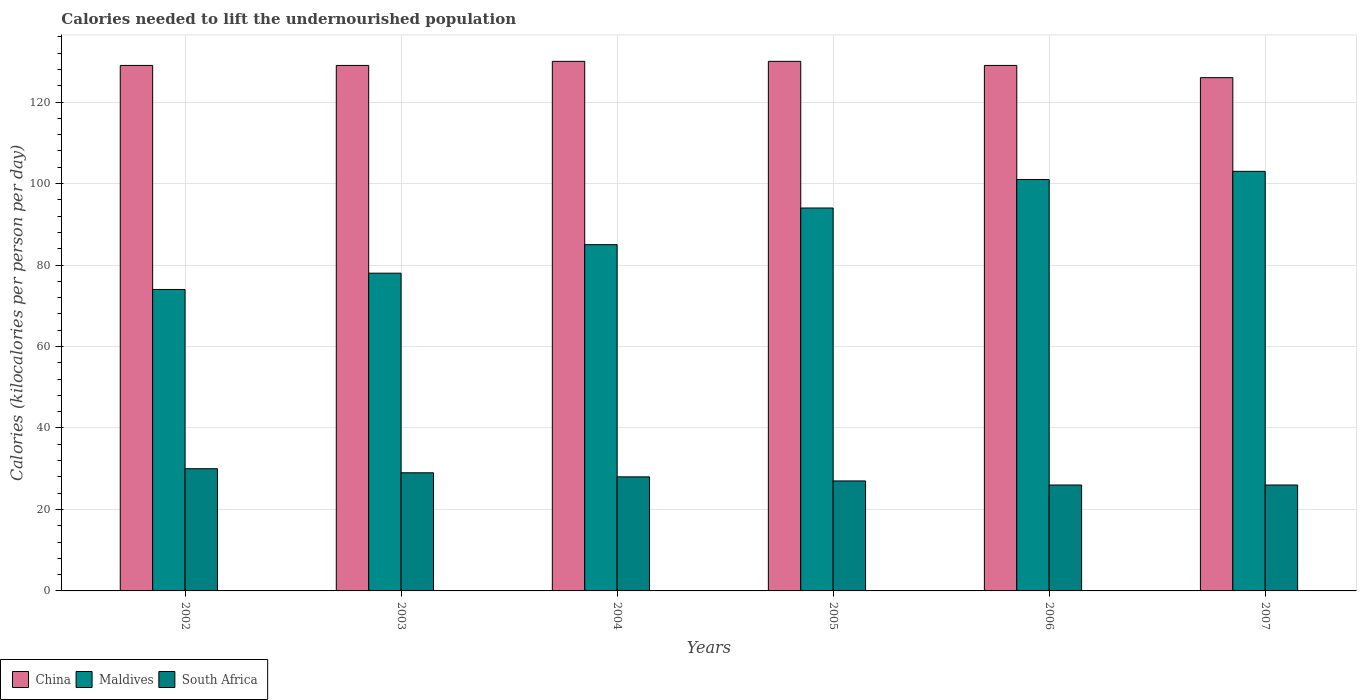How many different coloured bars are there?
Your response must be concise. 3. Are the number of bars per tick equal to the number of legend labels?
Keep it short and to the point. Yes. How many bars are there on the 3rd tick from the left?
Your answer should be compact. 3. What is the total calories needed to lift the undernourished population in China in 2003?
Ensure brevity in your answer.  129. Across all years, what is the maximum total calories needed to lift the undernourished population in South Africa?
Make the answer very short. 30. Across all years, what is the minimum total calories needed to lift the undernourished population in Maldives?
Offer a very short reply. 74. In which year was the total calories needed to lift the undernourished population in Maldives maximum?
Your answer should be compact. 2007. In which year was the total calories needed to lift the undernourished population in South Africa minimum?
Offer a very short reply. 2006. What is the total total calories needed to lift the undernourished population in Maldives in the graph?
Ensure brevity in your answer.  535. What is the difference between the total calories needed to lift the undernourished population in China in 2002 and that in 2005?
Provide a succinct answer. -1. What is the difference between the total calories needed to lift the undernourished population in South Africa in 2003 and the total calories needed to lift the undernourished population in Maldives in 2006?
Your response must be concise. -72. What is the average total calories needed to lift the undernourished population in Maldives per year?
Offer a very short reply. 89.17. In the year 2005, what is the difference between the total calories needed to lift the undernourished population in Maldives and total calories needed to lift the undernourished population in China?
Ensure brevity in your answer.  -36. In how many years, is the total calories needed to lift the undernourished population in South Africa greater than 96 kilocalories?
Your answer should be very brief. 0. What is the ratio of the total calories needed to lift the undernourished population in South Africa in 2005 to that in 2006?
Offer a terse response. 1.04. Is the total calories needed to lift the undernourished population in China in 2005 less than that in 2007?
Make the answer very short. No. Is the difference between the total calories needed to lift the undernourished population in Maldives in 2002 and 2007 greater than the difference between the total calories needed to lift the undernourished population in China in 2002 and 2007?
Your answer should be compact. No. What is the difference between the highest and the second highest total calories needed to lift the undernourished population in China?
Offer a terse response. 0. What is the difference between the highest and the lowest total calories needed to lift the undernourished population in Maldives?
Give a very brief answer. 29. Is the sum of the total calories needed to lift the undernourished population in China in 2002 and 2006 greater than the maximum total calories needed to lift the undernourished population in Maldives across all years?
Ensure brevity in your answer.  Yes. What does the 1st bar from the right in 2005 represents?
Your answer should be very brief. South Africa. Is it the case that in every year, the sum of the total calories needed to lift the undernourished population in Maldives and total calories needed to lift the undernourished population in China is greater than the total calories needed to lift the undernourished population in South Africa?
Make the answer very short. Yes. How many bars are there?
Keep it short and to the point. 18. Are all the bars in the graph horizontal?
Make the answer very short. No. What is the difference between two consecutive major ticks on the Y-axis?
Offer a terse response. 20. Does the graph contain grids?
Ensure brevity in your answer.  Yes. Where does the legend appear in the graph?
Keep it short and to the point. Bottom left. How many legend labels are there?
Your response must be concise. 3. How are the legend labels stacked?
Ensure brevity in your answer.  Horizontal. What is the title of the graph?
Offer a terse response. Calories needed to lift the undernourished population. Does "Uruguay" appear as one of the legend labels in the graph?
Make the answer very short. No. What is the label or title of the Y-axis?
Ensure brevity in your answer.  Calories (kilocalories per person per day). What is the Calories (kilocalories per person per day) of China in 2002?
Your answer should be very brief. 129. What is the Calories (kilocalories per person per day) of Maldives in 2002?
Make the answer very short. 74. What is the Calories (kilocalories per person per day) of China in 2003?
Your answer should be very brief. 129. What is the Calories (kilocalories per person per day) of Maldives in 2003?
Provide a short and direct response. 78. What is the Calories (kilocalories per person per day) in South Africa in 2003?
Make the answer very short. 29. What is the Calories (kilocalories per person per day) of China in 2004?
Make the answer very short. 130. What is the Calories (kilocalories per person per day) of Maldives in 2004?
Your answer should be very brief. 85. What is the Calories (kilocalories per person per day) in South Africa in 2004?
Your answer should be compact. 28. What is the Calories (kilocalories per person per day) in China in 2005?
Offer a very short reply. 130. What is the Calories (kilocalories per person per day) in Maldives in 2005?
Offer a very short reply. 94. What is the Calories (kilocalories per person per day) of South Africa in 2005?
Give a very brief answer. 27. What is the Calories (kilocalories per person per day) in China in 2006?
Ensure brevity in your answer.  129. What is the Calories (kilocalories per person per day) in Maldives in 2006?
Your answer should be compact. 101. What is the Calories (kilocalories per person per day) in South Africa in 2006?
Offer a very short reply. 26. What is the Calories (kilocalories per person per day) in China in 2007?
Your response must be concise. 126. What is the Calories (kilocalories per person per day) in Maldives in 2007?
Ensure brevity in your answer.  103. Across all years, what is the maximum Calories (kilocalories per person per day) in China?
Your answer should be very brief. 130. Across all years, what is the maximum Calories (kilocalories per person per day) in Maldives?
Offer a terse response. 103. Across all years, what is the maximum Calories (kilocalories per person per day) in South Africa?
Your answer should be very brief. 30. Across all years, what is the minimum Calories (kilocalories per person per day) in China?
Your answer should be very brief. 126. Across all years, what is the minimum Calories (kilocalories per person per day) in Maldives?
Your answer should be very brief. 74. What is the total Calories (kilocalories per person per day) of China in the graph?
Make the answer very short. 773. What is the total Calories (kilocalories per person per day) of Maldives in the graph?
Make the answer very short. 535. What is the total Calories (kilocalories per person per day) in South Africa in the graph?
Your answer should be compact. 166. What is the difference between the Calories (kilocalories per person per day) in Maldives in 2002 and that in 2003?
Your answer should be compact. -4. What is the difference between the Calories (kilocalories per person per day) of China in 2002 and that in 2004?
Your answer should be very brief. -1. What is the difference between the Calories (kilocalories per person per day) in South Africa in 2002 and that in 2004?
Your response must be concise. 2. What is the difference between the Calories (kilocalories per person per day) in Maldives in 2002 and that in 2005?
Provide a succinct answer. -20. What is the difference between the Calories (kilocalories per person per day) of South Africa in 2002 and that in 2005?
Provide a succinct answer. 3. What is the difference between the Calories (kilocalories per person per day) in Maldives in 2002 and that in 2006?
Offer a terse response. -27. What is the difference between the Calories (kilocalories per person per day) of South Africa in 2002 and that in 2006?
Your answer should be compact. 4. What is the difference between the Calories (kilocalories per person per day) of China in 2002 and that in 2007?
Ensure brevity in your answer.  3. What is the difference between the Calories (kilocalories per person per day) in South Africa in 2002 and that in 2007?
Provide a short and direct response. 4. What is the difference between the Calories (kilocalories per person per day) in China in 2003 and that in 2004?
Give a very brief answer. -1. What is the difference between the Calories (kilocalories per person per day) in Maldives in 2003 and that in 2004?
Your response must be concise. -7. What is the difference between the Calories (kilocalories per person per day) of South Africa in 2003 and that in 2004?
Provide a short and direct response. 1. What is the difference between the Calories (kilocalories per person per day) of China in 2003 and that in 2005?
Make the answer very short. -1. What is the difference between the Calories (kilocalories per person per day) in Maldives in 2003 and that in 2005?
Ensure brevity in your answer.  -16. What is the difference between the Calories (kilocalories per person per day) of South Africa in 2003 and that in 2005?
Provide a succinct answer. 2. What is the difference between the Calories (kilocalories per person per day) of China in 2003 and that in 2006?
Offer a terse response. 0. What is the difference between the Calories (kilocalories per person per day) of Maldives in 2003 and that in 2006?
Give a very brief answer. -23. What is the difference between the Calories (kilocalories per person per day) in China in 2003 and that in 2007?
Your answer should be very brief. 3. What is the difference between the Calories (kilocalories per person per day) in China in 2004 and that in 2005?
Your answer should be compact. 0. What is the difference between the Calories (kilocalories per person per day) in China in 2004 and that in 2006?
Offer a very short reply. 1. What is the difference between the Calories (kilocalories per person per day) in Maldives in 2004 and that in 2006?
Your answer should be compact. -16. What is the difference between the Calories (kilocalories per person per day) of Maldives in 2004 and that in 2007?
Your answer should be compact. -18. What is the difference between the Calories (kilocalories per person per day) in China in 2005 and that in 2006?
Your answer should be compact. 1. What is the difference between the Calories (kilocalories per person per day) in South Africa in 2005 and that in 2006?
Your answer should be very brief. 1. What is the difference between the Calories (kilocalories per person per day) of China in 2005 and that in 2007?
Offer a terse response. 4. What is the difference between the Calories (kilocalories per person per day) in Maldives in 2005 and that in 2007?
Offer a very short reply. -9. What is the difference between the Calories (kilocalories per person per day) in Maldives in 2006 and that in 2007?
Give a very brief answer. -2. What is the difference between the Calories (kilocalories per person per day) of South Africa in 2006 and that in 2007?
Offer a very short reply. 0. What is the difference between the Calories (kilocalories per person per day) of China in 2002 and the Calories (kilocalories per person per day) of Maldives in 2003?
Offer a terse response. 51. What is the difference between the Calories (kilocalories per person per day) in China in 2002 and the Calories (kilocalories per person per day) in South Africa in 2003?
Offer a terse response. 100. What is the difference between the Calories (kilocalories per person per day) of Maldives in 2002 and the Calories (kilocalories per person per day) of South Africa in 2003?
Offer a terse response. 45. What is the difference between the Calories (kilocalories per person per day) of China in 2002 and the Calories (kilocalories per person per day) of South Africa in 2004?
Your answer should be very brief. 101. What is the difference between the Calories (kilocalories per person per day) in China in 2002 and the Calories (kilocalories per person per day) in Maldives in 2005?
Ensure brevity in your answer.  35. What is the difference between the Calories (kilocalories per person per day) of China in 2002 and the Calories (kilocalories per person per day) of South Africa in 2005?
Your answer should be compact. 102. What is the difference between the Calories (kilocalories per person per day) of Maldives in 2002 and the Calories (kilocalories per person per day) of South Africa in 2005?
Ensure brevity in your answer.  47. What is the difference between the Calories (kilocalories per person per day) in China in 2002 and the Calories (kilocalories per person per day) in South Africa in 2006?
Provide a succinct answer. 103. What is the difference between the Calories (kilocalories per person per day) of Maldives in 2002 and the Calories (kilocalories per person per day) of South Africa in 2006?
Your answer should be compact. 48. What is the difference between the Calories (kilocalories per person per day) of China in 2002 and the Calories (kilocalories per person per day) of South Africa in 2007?
Make the answer very short. 103. What is the difference between the Calories (kilocalories per person per day) in China in 2003 and the Calories (kilocalories per person per day) in Maldives in 2004?
Ensure brevity in your answer.  44. What is the difference between the Calories (kilocalories per person per day) in China in 2003 and the Calories (kilocalories per person per day) in South Africa in 2004?
Your answer should be very brief. 101. What is the difference between the Calories (kilocalories per person per day) of China in 2003 and the Calories (kilocalories per person per day) of South Africa in 2005?
Make the answer very short. 102. What is the difference between the Calories (kilocalories per person per day) in Maldives in 2003 and the Calories (kilocalories per person per day) in South Africa in 2005?
Your response must be concise. 51. What is the difference between the Calories (kilocalories per person per day) of China in 2003 and the Calories (kilocalories per person per day) of South Africa in 2006?
Keep it short and to the point. 103. What is the difference between the Calories (kilocalories per person per day) of China in 2003 and the Calories (kilocalories per person per day) of South Africa in 2007?
Give a very brief answer. 103. What is the difference between the Calories (kilocalories per person per day) in Maldives in 2003 and the Calories (kilocalories per person per day) in South Africa in 2007?
Ensure brevity in your answer.  52. What is the difference between the Calories (kilocalories per person per day) of China in 2004 and the Calories (kilocalories per person per day) of South Africa in 2005?
Offer a terse response. 103. What is the difference between the Calories (kilocalories per person per day) of China in 2004 and the Calories (kilocalories per person per day) of South Africa in 2006?
Make the answer very short. 104. What is the difference between the Calories (kilocalories per person per day) in China in 2004 and the Calories (kilocalories per person per day) in Maldives in 2007?
Your response must be concise. 27. What is the difference between the Calories (kilocalories per person per day) in China in 2004 and the Calories (kilocalories per person per day) in South Africa in 2007?
Keep it short and to the point. 104. What is the difference between the Calories (kilocalories per person per day) in Maldives in 2004 and the Calories (kilocalories per person per day) in South Africa in 2007?
Give a very brief answer. 59. What is the difference between the Calories (kilocalories per person per day) of China in 2005 and the Calories (kilocalories per person per day) of Maldives in 2006?
Provide a succinct answer. 29. What is the difference between the Calories (kilocalories per person per day) of China in 2005 and the Calories (kilocalories per person per day) of South Africa in 2006?
Your answer should be very brief. 104. What is the difference between the Calories (kilocalories per person per day) in Maldives in 2005 and the Calories (kilocalories per person per day) in South Africa in 2006?
Make the answer very short. 68. What is the difference between the Calories (kilocalories per person per day) of China in 2005 and the Calories (kilocalories per person per day) of Maldives in 2007?
Your answer should be very brief. 27. What is the difference between the Calories (kilocalories per person per day) in China in 2005 and the Calories (kilocalories per person per day) in South Africa in 2007?
Offer a very short reply. 104. What is the difference between the Calories (kilocalories per person per day) in China in 2006 and the Calories (kilocalories per person per day) in South Africa in 2007?
Offer a very short reply. 103. What is the average Calories (kilocalories per person per day) in China per year?
Provide a short and direct response. 128.83. What is the average Calories (kilocalories per person per day) of Maldives per year?
Your answer should be compact. 89.17. What is the average Calories (kilocalories per person per day) of South Africa per year?
Offer a very short reply. 27.67. In the year 2003, what is the difference between the Calories (kilocalories per person per day) in China and Calories (kilocalories per person per day) in Maldives?
Provide a succinct answer. 51. In the year 2003, what is the difference between the Calories (kilocalories per person per day) of China and Calories (kilocalories per person per day) of South Africa?
Offer a very short reply. 100. In the year 2004, what is the difference between the Calories (kilocalories per person per day) in China and Calories (kilocalories per person per day) in Maldives?
Your answer should be compact. 45. In the year 2004, what is the difference between the Calories (kilocalories per person per day) of China and Calories (kilocalories per person per day) of South Africa?
Offer a terse response. 102. In the year 2004, what is the difference between the Calories (kilocalories per person per day) of Maldives and Calories (kilocalories per person per day) of South Africa?
Offer a very short reply. 57. In the year 2005, what is the difference between the Calories (kilocalories per person per day) of China and Calories (kilocalories per person per day) of South Africa?
Offer a terse response. 103. In the year 2005, what is the difference between the Calories (kilocalories per person per day) in Maldives and Calories (kilocalories per person per day) in South Africa?
Your response must be concise. 67. In the year 2006, what is the difference between the Calories (kilocalories per person per day) of China and Calories (kilocalories per person per day) of Maldives?
Make the answer very short. 28. In the year 2006, what is the difference between the Calories (kilocalories per person per day) of China and Calories (kilocalories per person per day) of South Africa?
Provide a short and direct response. 103. In the year 2007, what is the difference between the Calories (kilocalories per person per day) of Maldives and Calories (kilocalories per person per day) of South Africa?
Keep it short and to the point. 77. What is the ratio of the Calories (kilocalories per person per day) in China in 2002 to that in 2003?
Offer a very short reply. 1. What is the ratio of the Calories (kilocalories per person per day) in Maldives in 2002 to that in 2003?
Keep it short and to the point. 0.95. What is the ratio of the Calories (kilocalories per person per day) of South Africa in 2002 to that in 2003?
Keep it short and to the point. 1.03. What is the ratio of the Calories (kilocalories per person per day) in China in 2002 to that in 2004?
Give a very brief answer. 0.99. What is the ratio of the Calories (kilocalories per person per day) in Maldives in 2002 to that in 2004?
Ensure brevity in your answer.  0.87. What is the ratio of the Calories (kilocalories per person per day) of South Africa in 2002 to that in 2004?
Ensure brevity in your answer.  1.07. What is the ratio of the Calories (kilocalories per person per day) of Maldives in 2002 to that in 2005?
Provide a succinct answer. 0.79. What is the ratio of the Calories (kilocalories per person per day) in Maldives in 2002 to that in 2006?
Provide a succinct answer. 0.73. What is the ratio of the Calories (kilocalories per person per day) in South Africa in 2002 to that in 2006?
Your answer should be compact. 1.15. What is the ratio of the Calories (kilocalories per person per day) in China in 2002 to that in 2007?
Your response must be concise. 1.02. What is the ratio of the Calories (kilocalories per person per day) in Maldives in 2002 to that in 2007?
Provide a succinct answer. 0.72. What is the ratio of the Calories (kilocalories per person per day) in South Africa in 2002 to that in 2007?
Provide a succinct answer. 1.15. What is the ratio of the Calories (kilocalories per person per day) of Maldives in 2003 to that in 2004?
Ensure brevity in your answer.  0.92. What is the ratio of the Calories (kilocalories per person per day) of South Africa in 2003 to that in 2004?
Ensure brevity in your answer.  1.04. What is the ratio of the Calories (kilocalories per person per day) in Maldives in 2003 to that in 2005?
Your answer should be compact. 0.83. What is the ratio of the Calories (kilocalories per person per day) of South Africa in 2003 to that in 2005?
Make the answer very short. 1.07. What is the ratio of the Calories (kilocalories per person per day) in China in 2003 to that in 2006?
Offer a terse response. 1. What is the ratio of the Calories (kilocalories per person per day) of Maldives in 2003 to that in 2006?
Make the answer very short. 0.77. What is the ratio of the Calories (kilocalories per person per day) in South Africa in 2003 to that in 2006?
Offer a very short reply. 1.12. What is the ratio of the Calories (kilocalories per person per day) in China in 2003 to that in 2007?
Your answer should be very brief. 1.02. What is the ratio of the Calories (kilocalories per person per day) of Maldives in 2003 to that in 2007?
Your response must be concise. 0.76. What is the ratio of the Calories (kilocalories per person per day) of South Africa in 2003 to that in 2007?
Your answer should be very brief. 1.12. What is the ratio of the Calories (kilocalories per person per day) of Maldives in 2004 to that in 2005?
Keep it short and to the point. 0.9. What is the ratio of the Calories (kilocalories per person per day) in South Africa in 2004 to that in 2005?
Keep it short and to the point. 1.04. What is the ratio of the Calories (kilocalories per person per day) of China in 2004 to that in 2006?
Offer a terse response. 1.01. What is the ratio of the Calories (kilocalories per person per day) of Maldives in 2004 to that in 2006?
Offer a very short reply. 0.84. What is the ratio of the Calories (kilocalories per person per day) of South Africa in 2004 to that in 2006?
Offer a very short reply. 1.08. What is the ratio of the Calories (kilocalories per person per day) in China in 2004 to that in 2007?
Your answer should be very brief. 1.03. What is the ratio of the Calories (kilocalories per person per day) of Maldives in 2004 to that in 2007?
Ensure brevity in your answer.  0.83. What is the ratio of the Calories (kilocalories per person per day) of South Africa in 2004 to that in 2007?
Provide a succinct answer. 1.08. What is the ratio of the Calories (kilocalories per person per day) in Maldives in 2005 to that in 2006?
Make the answer very short. 0.93. What is the ratio of the Calories (kilocalories per person per day) of China in 2005 to that in 2007?
Make the answer very short. 1.03. What is the ratio of the Calories (kilocalories per person per day) in Maldives in 2005 to that in 2007?
Give a very brief answer. 0.91. What is the ratio of the Calories (kilocalories per person per day) of South Africa in 2005 to that in 2007?
Ensure brevity in your answer.  1.04. What is the ratio of the Calories (kilocalories per person per day) of China in 2006 to that in 2007?
Keep it short and to the point. 1.02. What is the ratio of the Calories (kilocalories per person per day) in Maldives in 2006 to that in 2007?
Give a very brief answer. 0.98. What is the difference between the highest and the lowest Calories (kilocalories per person per day) in South Africa?
Your response must be concise. 4. 